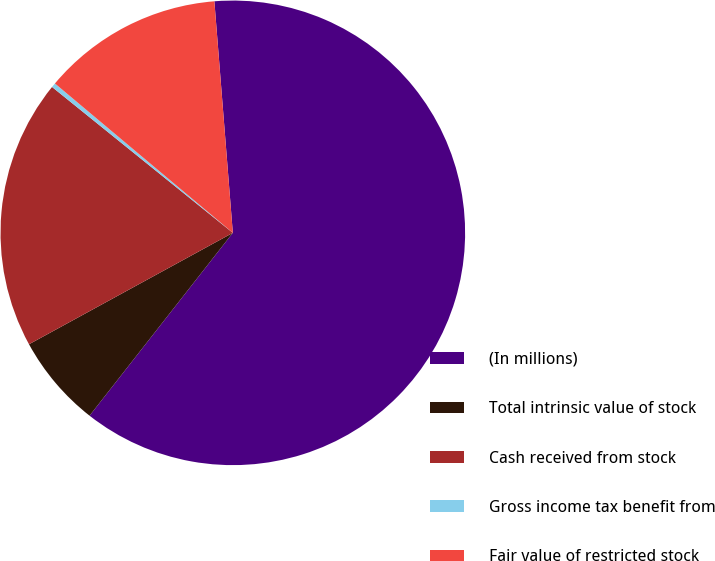Convert chart. <chart><loc_0><loc_0><loc_500><loc_500><pie_chart><fcel>(In millions)<fcel>Total intrinsic value of stock<fcel>Cash received from stock<fcel>Gross income tax benefit from<fcel>Fair value of restricted stock<nl><fcel>61.85%<fcel>6.46%<fcel>18.77%<fcel>0.31%<fcel>12.62%<nl></chart> 